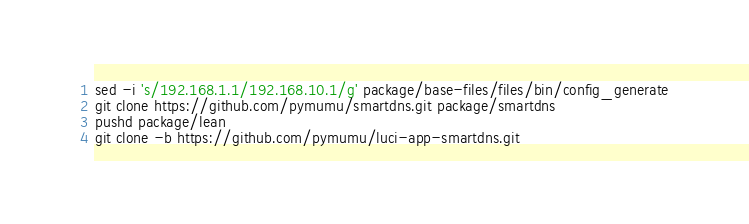Convert code to text. <code><loc_0><loc_0><loc_500><loc_500><_Bash_>sed -i 's/192.168.1.1/192.168.10.1/g' package/base-files/files/bin/config_generate
git clone https://github.com/pymumu/smartdns.git package/smartdns
pushd package/lean
git clone -b https://github.com/pymumu/luci-app-smartdns.git
</code> 